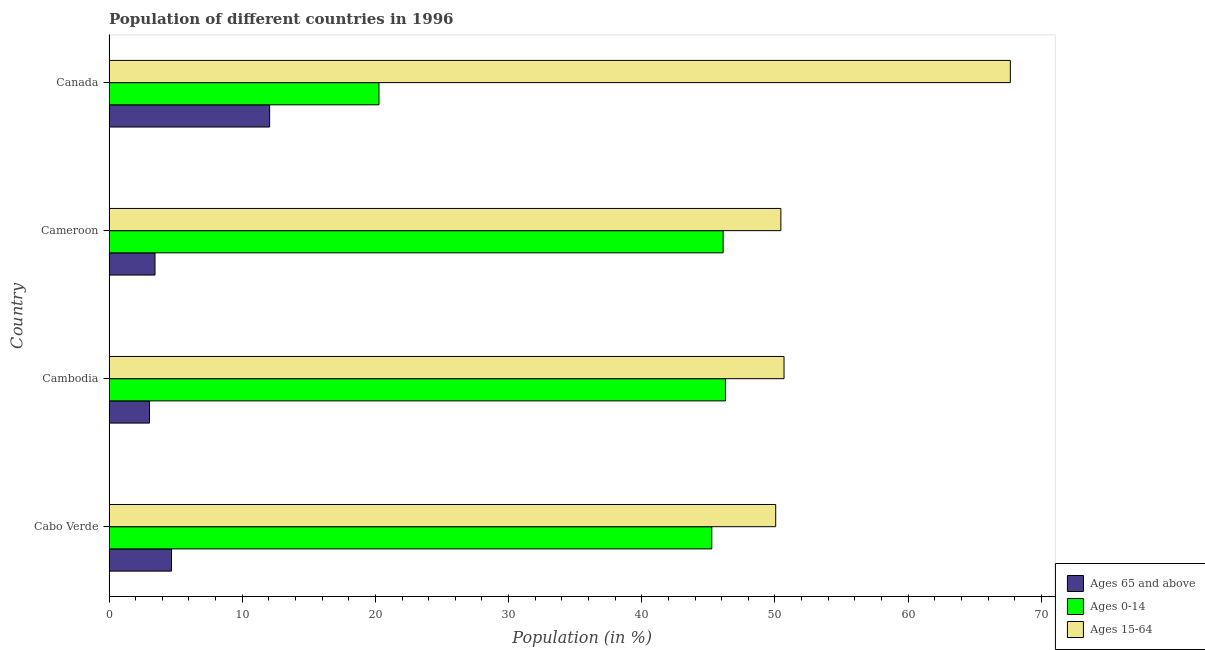How many different coloured bars are there?
Make the answer very short. 3. Are the number of bars per tick equal to the number of legend labels?
Your answer should be compact. Yes. Are the number of bars on each tick of the Y-axis equal?
Offer a terse response. Yes. What is the label of the 3rd group of bars from the top?
Provide a short and direct response. Cambodia. In how many cases, is the number of bars for a given country not equal to the number of legend labels?
Your answer should be compact. 0. What is the percentage of population within the age-group of 65 and above in Cabo Verde?
Your answer should be compact. 4.69. Across all countries, what is the maximum percentage of population within the age-group 0-14?
Offer a very short reply. 46.28. Across all countries, what is the minimum percentage of population within the age-group of 65 and above?
Your response must be concise. 3.04. In which country was the percentage of population within the age-group 0-14 maximum?
Make the answer very short. Cambodia. In which country was the percentage of population within the age-group of 65 and above minimum?
Your response must be concise. Cambodia. What is the total percentage of population within the age-group 15-64 in the graph?
Give a very brief answer. 218.85. What is the difference between the percentage of population within the age-group 0-14 in Cabo Verde and that in Cameroon?
Keep it short and to the point. -0.85. What is the difference between the percentage of population within the age-group 15-64 in Canada and the percentage of population within the age-group 0-14 in Cabo Verde?
Give a very brief answer. 22.42. What is the average percentage of population within the age-group of 65 and above per country?
Provide a short and direct response. 5.81. What is the difference between the percentage of population within the age-group of 65 and above and percentage of population within the age-group 0-14 in Cameroon?
Provide a short and direct response. -42.66. In how many countries, is the percentage of population within the age-group 15-64 greater than 60 %?
Your response must be concise. 1. What is the ratio of the percentage of population within the age-group 0-14 in Cambodia to that in Canada?
Provide a short and direct response. 2.28. Is the percentage of population within the age-group 15-64 in Cambodia less than that in Cameroon?
Provide a short and direct response. No. What is the difference between the highest and the second highest percentage of population within the age-group 0-14?
Keep it short and to the point. 0.17. What is the difference between the highest and the lowest percentage of population within the age-group of 65 and above?
Your answer should be very brief. 9.02. What does the 2nd bar from the top in Cameroon represents?
Your answer should be very brief. Ages 0-14. What does the 1st bar from the bottom in Cambodia represents?
Keep it short and to the point. Ages 65 and above. Are all the bars in the graph horizontal?
Your response must be concise. Yes. Are the values on the major ticks of X-axis written in scientific E-notation?
Your answer should be compact. No. Does the graph contain grids?
Give a very brief answer. No. What is the title of the graph?
Ensure brevity in your answer.  Population of different countries in 1996. What is the label or title of the Y-axis?
Offer a very short reply. Country. What is the Population (in %) in Ages 65 and above in Cabo Verde?
Give a very brief answer. 4.69. What is the Population (in %) of Ages 0-14 in Cabo Verde?
Provide a succinct answer. 45.26. What is the Population (in %) of Ages 15-64 in Cabo Verde?
Give a very brief answer. 50.06. What is the Population (in %) in Ages 65 and above in Cambodia?
Provide a succinct answer. 3.04. What is the Population (in %) of Ages 0-14 in Cambodia?
Offer a very short reply. 46.28. What is the Population (in %) of Ages 15-64 in Cambodia?
Offer a very short reply. 50.68. What is the Population (in %) in Ages 65 and above in Cameroon?
Make the answer very short. 3.45. What is the Population (in %) of Ages 0-14 in Cameroon?
Keep it short and to the point. 46.11. What is the Population (in %) of Ages 15-64 in Cameroon?
Offer a terse response. 50.44. What is the Population (in %) of Ages 65 and above in Canada?
Offer a very short reply. 12.06. What is the Population (in %) of Ages 0-14 in Canada?
Offer a very short reply. 20.27. What is the Population (in %) of Ages 15-64 in Canada?
Offer a terse response. 67.67. Across all countries, what is the maximum Population (in %) in Ages 65 and above?
Your response must be concise. 12.06. Across all countries, what is the maximum Population (in %) of Ages 0-14?
Give a very brief answer. 46.28. Across all countries, what is the maximum Population (in %) in Ages 15-64?
Offer a terse response. 67.67. Across all countries, what is the minimum Population (in %) of Ages 65 and above?
Keep it short and to the point. 3.04. Across all countries, what is the minimum Population (in %) of Ages 0-14?
Offer a very short reply. 20.27. Across all countries, what is the minimum Population (in %) of Ages 15-64?
Your answer should be very brief. 50.06. What is the total Population (in %) of Ages 65 and above in the graph?
Keep it short and to the point. 23.23. What is the total Population (in %) of Ages 0-14 in the graph?
Provide a short and direct response. 157.91. What is the total Population (in %) of Ages 15-64 in the graph?
Offer a very short reply. 218.85. What is the difference between the Population (in %) in Ages 65 and above in Cabo Verde and that in Cambodia?
Offer a very short reply. 1.65. What is the difference between the Population (in %) of Ages 0-14 in Cabo Verde and that in Cambodia?
Make the answer very short. -1.03. What is the difference between the Population (in %) of Ages 15-64 in Cabo Verde and that in Cambodia?
Keep it short and to the point. -0.63. What is the difference between the Population (in %) in Ages 65 and above in Cabo Verde and that in Cameroon?
Give a very brief answer. 1.24. What is the difference between the Population (in %) of Ages 0-14 in Cabo Verde and that in Cameroon?
Offer a very short reply. -0.85. What is the difference between the Population (in %) of Ages 15-64 in Cabo Verde and that in Cameroon?
Keep it short and to the point. -0.39. What is the difference between the Population (in %) of Ages 65 and above in Cabo Verde and that in Canada?
Offer a terse response. -7.37. What is the difference between the Population (in %) of Ages 0-14 in Cabo Verde and that in Canada?
Provide a short and direct response. 24.99. What is the difference between the Population (in %) of Ages 15-64 in Cabo Verde and that in Canada?
Make the answer very short. -17.62. What is the difference between the Population (in %) in Ages 65 and above in Cambodia and that in Cameroon?
Provide a short and direct response. -0.41. What is the difference between the Population (in %) in Ages 0-14 in Cambodia and that in Cameroon?
Offer a terse response. 0.17. What is the difference between the Population (in %) in Ages 15-64 in Cambodia and that in Cameroon?
Your response must be concise. 0.24. What is the difference between the Population (in %) of Ages 65 and above in Cambodia and that in Canada?
Provide a short and direct response. -9.02. What is the difference between the Population (in %) of Ages 0-14 in Cambodia and that in Canada?
Give a very brief answer. 26.01. What is the difference between the Population (in %) of Ages 15-64 in Cambodia and that in Canada?
Your response must be concise. -16.99. What is the difference between the Population (in %) in Ages 65 and above in Cameroon and that in Canada?
Offer a terse response. -8.61. What is the difference between the Population (in %) in Ages 0-14 in Cameroon and that in Canada?
Your answer should be compact. 25.84. What is the difference between the Population (in %) in Ages 15-64 in Cameroon and that in Canada?
Your response must be concise. -17.23. What is the difference between the Population (in %) of Ages 65 and above in Cabo Verde and the Population (in %) of Ages 0-14 in Cambodia?
Keep it short and to the point. -41.59. What is the difference between the Population (in %) of Ages 65 and above in Cabo Verde and the Population (in %) of Ages 15-64 in Cambodia?
Make the answer very short. -45.99. What is the difference between the Population (in %) in Ages 0-14 in Cabo Verde and the Population (in %) in Ages 15-64 in Cambodia?
Keep it short and to the point. -5.42. What is the difference between the Population (in %) of Ages 65 and above in Cabo Verde and the Population (in %) of Ages 0-14 in Cameroon?
Your answer should be compact. -41.42. What is the difference between the Population (in %) of Ages 65 and above in Cabo Verde and the Population (in %) of Ages 15-64 in Cameroon?
Make the answer very short. -45.75. What is the difference between the Population (in %) in Ages 0-14 in Cabo Verde and the Population (in %) in Ages 15-64 in Cameroon?
Your response must be concise. -5.19. What is the difference between the Population (in %) of Ages 65 and above in Cabo Verde and the Population (in %) of Ages 0-14 in Canada?
Offer a very short reply. -15.58. What is the difference between the Population (in %) in Ages 65 and above in Cabo Verde and the Population (in %) in Ages 15-64 in Canada?
Your response must be concise. -62.99. What is the difference between the Population (in %) in Ages 0-14 in Cabo Verde and the Population (in %) in Ages 15-64 in Canada?
Offer a terse response. -22.42. What is the difference between the Population (in %) of Ages 65 and above in Cambodia and the Population (in %) of Ages 0-14 in Cameroon?
Ensure brevity in your answer.  -43.07. What is the difference between the Population (in %) of Ages 65 and above in Cambodia and the Population (in %) of Ages 15-64 in Cameroon?
Make the answer very short. -47.41. What is the difference between the Population (in %) in Ages 0-14 in Cambodia and the Population (in %) in Ages 15-64 in Cameroon?
Give a very brief answer. -4.16. What is the difference between the Population (in %) in Ages 65 and above in Cambodia and the Population (in %) in Ages 0-14 in Canada?
Your response must be concise. -17.23. What is the difference between the Population (in %) of Ages 65 and above in Cambodia and the Population (in %) of Ages 15-64 in Canada?
Offer a terse response. -64.64. What is the difference between the Population (in %) in Ages 0-14 in Cambodia and the Population (in %) in Ages 15-64 in Canada?
Provide a short and direct response. -21.39. What is the difference between the Population (in %) of Ages 65 and above in Cameroon and the Population (in %) of Ages 0-14 in Canada?
Your answer should be very brief. -16.82. What is the difference between the Population (in %) of Ages 65 and above in Cameroon and the Population (in %) of Ages 15-64 in Canada?
Keep it short and to the point. -64.23. What is the difference between the Population (in %) in Ages 0-14 in Cameroon and the Population (in %) in Ages 15-64 in Canada?
Provide a succinct answer. -21.57. What is the average Population (in %) of Ages 65 and above per country?
Offer a very short reply. 5.81. What is the average Population (in %) in Ages 0-14 per country?
Keep it short and to the point. 39.48. What is the average Population (in %) of Ages 15-64 per country?
Ensure brevity in your answer.  54.71. What is the difference between the Population (in %) in Ages 65 and above and Population (in %) in Ages 0-14 in Cabo Verde?
Give a very brief answer. -40.57. What is the difference between the Population (in %) in Ages 65 and above and Population (in %) in Ages 15-64 in Cabo Verde?
Make the answer very short. -45.37. What is the difference between the Population (in %) in Ages 0-14 and Population (in %) in Ages 15-64 in Cabo Verde?
Your answer should be compact. -4.8. What is the difference between the Population (in %) of Ages 65 and above and Population (in %) of Ages 0-14 in Cambodia?
Your response must be concise. -43.24. What is the difference between the Population (in %) in Ages 65 and above and Population (in %) in Ages 15-64 in Cambodia?
Provide a short and direct response. -47.64. What is the difference between the Population (in %) of Ages 0-14 and Population (in %) of Ages 15-64 in Cambodia?
Your response must be concise. -4.4. What is the difference between the Population (in %) in Ages 65 and above and Population (in %) in Ages 0-14 in Cameroon?
Your response must be concise. -42.66. What is the difference between the Population (in %) of Ages 65 and above and Population (in %) of Ages 15-64 in Cameroon?
Provide a short and direct response. -46.99. What is the difference between the Population (in %) of Ages 0-14 and Population (in %) of Ages 15-64 in Cameroon?
Provide a short and direct response. -4.33. What is the difference between the Population (in %) in Ages 65 and above and Population (in %) in Ages 0-14 in Canada?
Provide a short and direct response. -8.21. What is the difference between the Population (in %) in Ages 65 and above and Population (in %) in Ages 15-64 in Canada?
Provide a short and direct response. -55.62. What is the difference between the Population (in %) of Ages 0-14 and Population (in %) of Ages 15-64 in Canada?
Your answer should be very brief. -47.41. What is the ratio of the Population (in %) of Ages 65 and above in Cabo Verde to that in Cambodia?
Offer a terse response. 1.54. What is the ratio of the Population (in %) in Ages 0-14 in Cabo Verde to that in Cambodia?
Provide a short and direct response. 0.98. What is the ratio of the Population (in %) of Ages 65 and above in Cabo Verde to that in Cameroon?
Provide a succinct answer. 1.36. What is the ratio of the Population (in %) in Ages 0-14 in Cabo Verde to that in Cameroon?
Offer a very short reply. 0.98. What is the ratio of the Population (in %) in Ages 65 and above in Cabo Verde to that in Canada?
Give a very brief answer. 0.39. What is the ratio of the Population (in %) in Ages 0-14 in Cabo Verde to that in Canada?
Offer a terse response. 2.23. What is the ratio of the Population (in %) in Ages 15-64 in Cabo Verde to that in Canada?
Provide a short and direct response. 0.74. What is the ratio of the Population (in %) of Ages 65 and above in Cambodia to that in Cameroon?
Give a very brief answer. 0.88. What is the ratio of the Population (in %) in Ages 0-14 in Cambodia to that in Cameroon?
Give a very brief answer. 1. What is the ratio of the Population (in %) in Ages 15-64 in Cambodia to that in Cameroon?
Your answer should be compact. 1. What is the ratio of the Population (in %) in Ages 65 and above in Cambodia to that in Canada?
Your answer should be very brief. 0.25. What is the ratio of the Population (in %) of Ages 0-14 in Cambodia to that in Canada?
Offer a terse response. 2.28. What is the ratio of the Population (in %) in Ages 15-64 in Cambodia to that in Canada?
Offer a terse response. 0.75. What is the ratio of the Population (in %) of Ages 65 and above in Cameroon to that in Canada?
Provide a succinct answer. 0.29. What is the ratio of the Population (in %) of Ages 0-14 in Cameroon to that in Canada?
Ensure brevity in your answer.  2.27. What is the ratio of the Population (in %) in Ages 15-64 in Cameroon to that in Canada?
Make the answer very short. 0.75. What is the difference between the highest and the second highest Population (in %) in Ages 65 and above?
Provide a succinct answer. 7.37. What is the difference between the highest and the second highest Population (in %) of Ages 0-14?
Provide a short and direct response. 0.17. What is the difference between the highest and the second highest Population (in %) in Ages 15-64?
Provide a succinct answer. 16.99. What is the difference between the highest and the lowest Population (in %) in Ages 65 and above?
Offer a very short reply. 9.02. What is the difference between the highest and the lowest Population (in %) in Ages 0-14?
Give a very brief answer. 26.01. What is the difference between the highest and the lowest Population (in %) of Ages 15-64?
Ensure brevity in your answer.  17.62. 